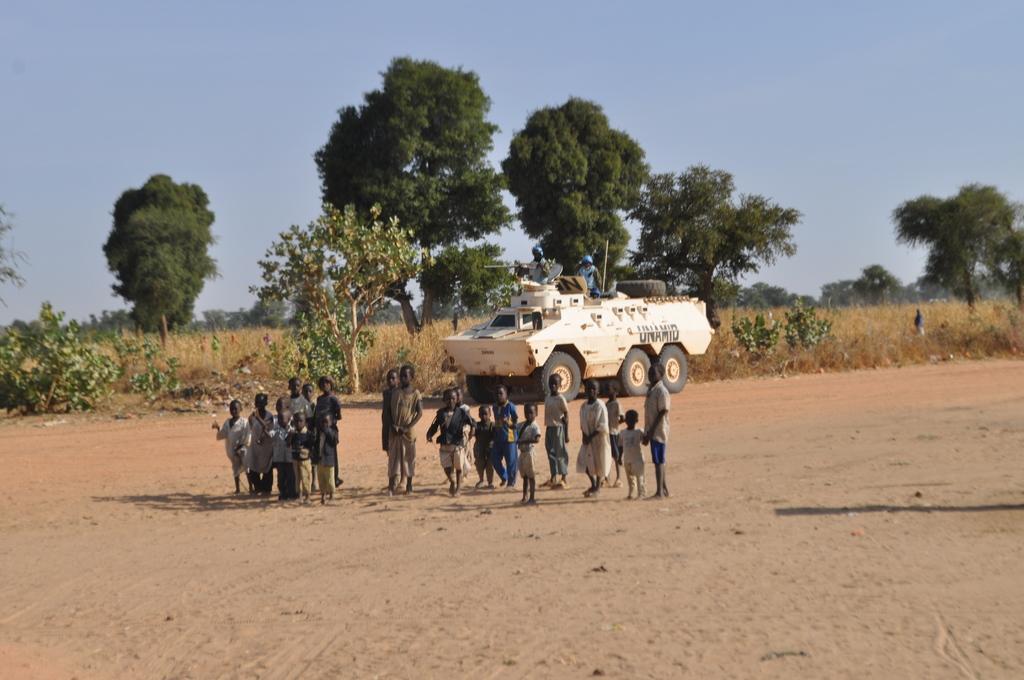In one or two sentences, can you explain what this image depicts? In this image in the center there is one vehicle and some children are standing. At the bottom there is sand and in the background there are some trees, plants and some grass. At the top there is sky. 